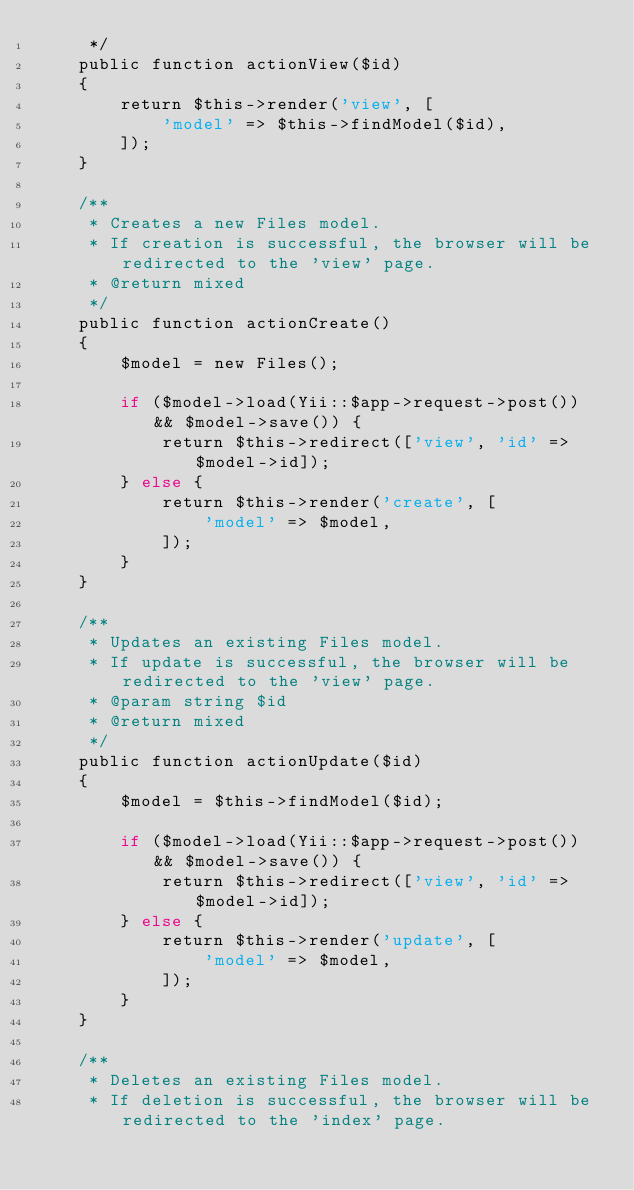<code> <loc_0><loc_0><loc_500><loc_500><_PHP_>     */
    public function actionView($id)
    {
        return $this->render('view', [
            'model' => $this->findModel($id),
        ]);
    }

    /**
     * Creates a new Files model.
     * If creation is successful, the browser will be redirected to the 'view' page.
     * @return mixed
     */
    public function actionCreate()
    {
        $model = new Files();

        if ($model->load(Yii::$app->request->post()) && $model->save()) {
            return $this->redirect(['view', 'id' => $model->id]);
        } else {
            return $this->render('create', [
                'model' => $model,
            ]);
        }
    }

    /**
     * Updates an existing Files model.
     * If update is successful, the browser will be redirected to the 'view' page.
     * @param string $id
     * @return mixed
     */
    public function actionUpdate($id)
    {
        $model = $this->findModel($id);

        if ($model->load(Yii::$app->request->post()) && $model->save()) {
            return $this->redirect(['view', 'id' => $model->id]);
        } else {
            return $this->render('update', [
                'model' => $model,
            ]);
        }
    }

    /**
     * Deletes an existing Files model.
     * If deletion is successful, the browser will be redirected to the 'index' page.</code> 